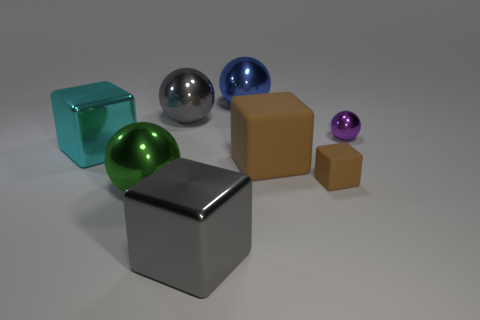Subtract 1 blocks. How many blocks are left? 3 Subtract all cyan blocks. Subtract all yellow balls. How many blocks are left? 3 Add 1 blocks. How many objects exist? 9 Add 6 big cyan things. How many big cyan things are left? 7 Add 2 big cyan cylinders. How many big cyan cylinders exist? 2 Subtract 0 purple cubes. How many objects are left? 8 Subtract all cyan blocks. Subtract all big balls. How many objects are left? 4 